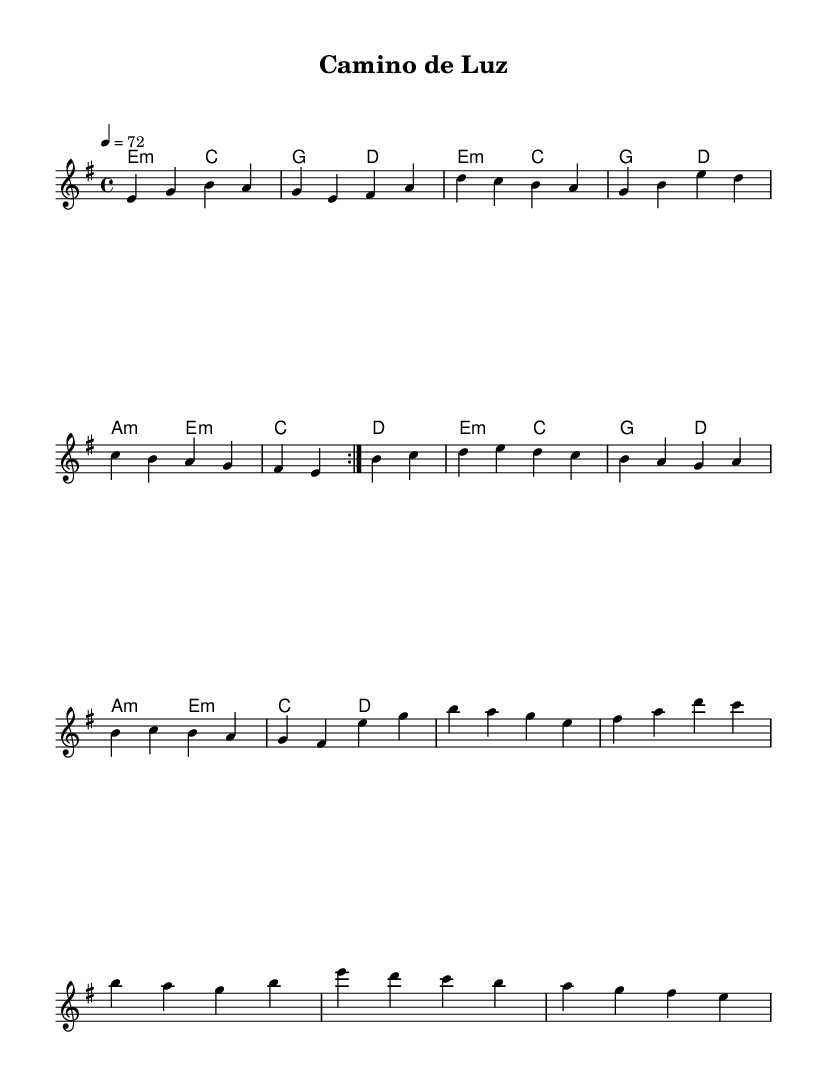What is the key signature of this music? The key signature is E minor, which is characterized by one sharp (F#).
Answer: E minor What is the time signature of this music? The time signature is 4/4, indicating that there are four beats in each measure.
Answer: 4/4 What is the tempo marking? The tempo marking is 72 beats per minute, as indicated by the tempo symbol '4 = 72'.
Answer: 72 How many measures are in the melody? The melody contains a total of 16 measures, based on the grouping of notes shown in the music.
Answer: 16 What is the mood suggested by the harmonies? The harmonies primarily consist of minor chords, suggesting a reflective or melancholic mood.
Answer: Reflective How does the structure of the harmony support the melody? The structure of the harmony predominantly uses E minor and its related chords, providing a harmonic foundation that complements and enhances the emotional quality of the melody.
Answer: Complements melody What makes this music a Latin rock ballad? The music features a blend of rock rhythms with Latin influences, specifically in the melodic phrasing and harmonic structure, typical of Latin rock ballads.
Answer: Latin rock ballad 